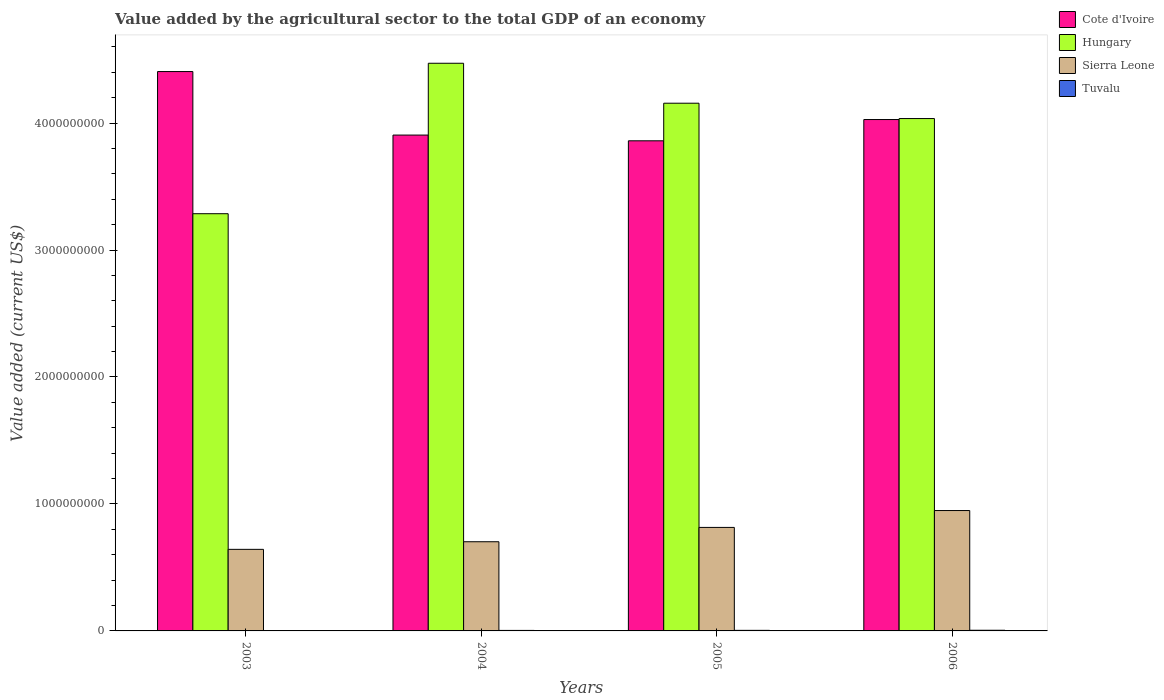How many groups of bars are there?
Offer a very short reply. 4. Are the number of bars on each tick of the X-axis equal?
Give a very brief answer. Yes. How many bars are there on the 1st tick from the left?
Ensure brevity in your answer.  4. How many bars are there on the 1st tick from the right?
Your answer should be compact. 4. What is the value added by the agricultural sector to the total GDP in Sierra Leone in 2006?
Ensure brevity in your answer.  9.48e+08. Across all years, what is the maximum value added by the agricultural sector to the total GDP in Sierra Leone?
Your answer should be compact. 9.48e+08. Across all years, what is the minimum value added by the agricultural sector to the total GDP in Tuvalu?
Offer a very short reply. 3.17e+06. In which year was the value added by the agricultural sector to the total GDP in Cote d'Ivoire maximum?
Your response must be concise. 2003. What is the total value added by the agricultural sector to the total GDP in Hungary in the graph?
Your answer should be very brief. 1.59e+1. What is the difference between the value added by the agricultural sector to the total GDP in Sierra Leone in 2004 and that in 2006?
Ensure brevity in your answer.  -2.46e+08. What is the difference between the value added by the agricultural sector to the total GDP in Tuvalu in 2003 and the value added by the agricultural sector to the total GDP in Sierra Leone in 2005?
Ensure brevity in your answer.  -8.12e+08. What is the average value added by the agricultural sector to the total GDP in Cote d'Ivoire per year?
Provide a short and direct response. 4.05e+09. In the year 2005, what is the difference between the value added by the agricultural sector to the total GDP in Hungary and value added by the agricultural sector to the total GDP in Tuvalu?
Offer a very short reply. 4.15e+09. What is the ratio of the value added by the agricultural sector to the total GDP in Hungary in 2003 to that in 2006?
Your response must be concise. 0.81. Is the difference between the value added by the agricultural sector to the total GDP in Hungary in 2003 and 2004 greater than the difference between the value added by the agricultural sector to the total GDP in Tuvalu in 2003 and 2004?
Give a very brief answer. No. What is the difference between the highest and the second highest value added by the agricultural sector to the total GDP in Cote d'Ivoire?
Provide a succinct answer. 3.78e+08. What is the difference between the highest and the lowest value added by the agricultural sector to the total GDP in Hungary?
Your answer should be very brief. 1.18e+09. In how many years, is the value added by the agricultural sector to the total GDP in Cote d'Ivoire greater than the average value added by the agricultural sector to the total GDP in Cote d'Ivoire taken over all years?
Your answer should be very brief. 1. Is the sum of the value added by the agricultural sector to the total GDP in Cote d'Ivoire in 2004 and 2005 greater than the maximum value added by the agricultural sector to the total GDP in Tuvalu across all years?
Your answer should be compact. Yes. Is it the case that in every year, the sum of the value added by the agricultural sector to the total GDP in Sierra Leone and value added by the agricultural sector to the total GDP in Cote d'Ivoire is greater than the sum of value added by the agricultural sector to the total GDP in Hungary and value added by the agricultural sector to the total GDP in Tuvalu?
Keep it short and to the point. Yes. What does the 1st bar from the left in 2005 represents?
Offer a very short reply. Cote d'Ivoire. What does the 4th bar from the right in 2006 represents?
Keep it short and to the point. Cote d'Ivoire. Are all the bars in the graph horizontal?
Keep it short and to the point. No. What is the difference between two consecutive major ticks on the Y-axis?
Your response must be concise. 1.00e+09. Does the graph contain any zero values?
Provide a succinct answer. No. How many legend labels are there?
Your response must be concise. 4. How are the legend labels stacked?
Keep it short and to the point. Vertical. What is the title of the graph?
Give a very brief answer. Value added by the agricultural sector to the total GDP of an economy. What is the label or title of the X-axis?
Provide a succinct answer. Years. What is the label or title of the Y-axis?
Offer a terse response. Value added (current US$). What is the Value added (current US$) in Cote d'Ivoire in 2003?
Provide a short and direct response. 4.41e+09. What is the Value added (current US$) in Hungary in 2003?
Keep it short and to the point. 3.29e+09. What is the Value added (current US$) in Sierra Leone in 2003?
Keep it short and to the point. 6.42e+08. What is the Value added (current US$) in Tuvalu in 2003?
Provide a short and direct response. 3.17e+06. What is the Value added (current US$) of Cote d'Ivoire in 2004?
Ensure brevity in your answer.  3.91e+09. What is the Value added (current US$) in Hungary in 2004?
Give a very brief answer. 4.47e+09. What is the Value added (current US$) of Sierra Leone in 2004?
Give a very brief answer. 7.02e+08. What is the Value added (current US$) of Tuvalu in 2004?
Offer a terse response. 4.02e+06. What is the Value added (current US$) in Cote d'Ivoire in 2005?
Ensure brevity in your answer.  3.86e+09. What is the Value added (current US$) of Hungary in 2005?
Your answer should be compact. 4.16e+09. What is the Value added (current US$) of Sierra Leone in 2005?
Keep it short and to the point. 8.15e+08. What is the Value added (current US$) of Tuvalu in 2005?
Offer a terse response. 4.45e+06. What is the Value added (current US$) in Cote d'Ivoire in 2006?
Your answer should be compact. 4.03e+09. What is the Value added (current US$) of Hungary in 2006?
Offer a terse response. 4.04e+09. What is the Value added (current US$) of Sierra Leone in 2006?
Give a very brief answer. 9.48e+08. What is the Value added (current US$) in Tuvalu in 2006?
Your answer should be very brief. 5.22e+06. Across all years, what is the maximum Value added (current US$) in Cote d'Ivoire?
Offer a terse response. 4.41e+09. Across all years, what is the maximum Value added (current US$) in Hungary?
Your answer should be very brief. 4.47e+09. Across all years, what is the maximum Value added (current US$) of Sierra Leone?
Provide a succinct answer. 9.48e+08. Across all years, what is the maximum Value added (current US$) of Tuvalu?
Give a very brief answer. 5.22e+06. Across all years, what is the minimum Value added (current US$) of Cote d'Ivoire?
Provide a short and direct response. 3.86e+09. Across all years, what is the minimum Value added (current US$) of Hungary?
Provide a succinct answer. 3.29e+09. Across all years, what is the minimum Value added (current US$) in Sierra Leone?
Provide a succinct answer. 6.42e+08. Across all years, what is the minimum Value added (current US$) of Tuvalu?
Make the answer very short. 3.17e+06. What is the total Value added (current US$) in Cote d'Ivoire in the graph?
Make the answer very short. 1.62e+1. What is the total Value added (current US$) of Hungary in the graph?
Give a very brief answer. 1.59e+1. What is the total Value added (current US$) of Sierra Leone in the graph?
Make the answer very short. 3.11e+09. What is the total Value added (current US$) in Tuvalu in the graph?
Give a very brief answer. 1.69e+07. What is the difference between the Value added (current US$) of Cote d'Ivoire in 2003 and that in 2004?
Give a very brief answer. 5.00e+08. What is the difference between the Value added (current US$) in Hungary in 2003 and that in 2004?
Your response must be concise. -1.18e+09. What is the difference between the Value added (current US$) of Sierra Leone in 2003 and that in 2004?
Make the answer very short. -5.99e+07. What is the difference between the Value added (current US$) of Tuvalu in 2003 and that in 2004?
Ensure brevity in your answer.  -8.54e+05. What is the difference between the Value added (current US$) of Cote d'Ivoire in 2003 and that in 2005?
Offer a terse response. 5.45e+08. What is the difference between the Value added (current US$) of Hungary in 2003 and that in 2005?
Your answer should be very brief. -8.70e+08. What is the difference between the Value added (current US$) in Sierra Leone in 2003 and that in 2005?
Your answer should be compact. -1.73e+08. What is the difference between the Value added (current US$) in Tuvalu in 2003 and that in 2005?
Provide a succinct answer. -1.28e+06. What is the difference between the Value added (current US$) of Cote d'Ivoire in 2003 and that in 2006?
Offer a very short reply. 3.78e+08. What is the difference between the Value added (current US$) in Hungary in 2003 and that in 2006?
Keep it short and to the point. -7.49e+08. What is the difference between the Value added (current US$) in Sierra Leone in 2003 and that in 2006?
Your answer should be compact. -3.06e+08. What is the difference between the Value added (current US$) of Tuvalu in 2003 and that in 2006?
Make the answer very short. -2.05e+06. What is the difference between the Value added (current US$) of Cote d'Ivoire in 2004 and that in 2005?
Your response must be concise. 4.51e+07. What is the difference between the Value added (current US$) in Hungary in 2004 and that in 2005?
Give a very brief answer. 3.15e+08. What is the difference between the Value added (current US$) in Sierra Leone in 2004 and that in 2005?
Your answer should be very brief. -1.13e+08. What is the difference between the Value added (current US$) in Tuvalu in 2004 and that in 2005?
Ensure brevity in your answer.  -4.29e+05. What is the difference between the Value added (current US$) of Cote d'Ivoire in 2004 and that in 2006?
Your answer should be very brief. -1.22e+08. What is the difference between the Value added (current US$) of Hungary in 2004 and that in 2006?
Offer a terse response. 4.35e+08. What is the difference between the Value added (current US$) in Sierra Leone in 2004 and that in 2006?
Provide a short and direct response. -2.46e+08. What is the difference between the Value added (current US$) of Tuvalu in 2004 and that in 2006?
Keep it short and to the point. -1.20e+06. What is the difference between the Value added (current US$) of Cote d'Ivoire in 2005 and that in 2006?
Your response must be concise. -1.67e+08. What is the difference between the Value added (current US$) in Hungary in 2005 and that in 2006?
Your response must be concise. 1.21e+08. What is the difference between the Value added (current US$) of Sierra Leone in 2005 and that in 2006?
Your answer should be compact. -1.33e+08. What is the difference between the Value added (current US$) in Tuvalu in 2005 and that in 2006?
Offer a very short reply. -7.67e+05. What is the difference between the Value added (current US$) of Cote d'Ivoire in 2003 and the Value added (current US$) of Hungary in 2004?
Provide a succinct answer. -6.54e+07. What is the difference between the Value added (current US$) of Cote d'Ivoire in 2003 and the Value added (current US$) of Sierra Leone in 2004?
Offer a terse response. 3.70e+09. What is the difference between the Value added (current US$) in Cote d'Ivoire in 2003 and the Value added (current US$) in Tuvalu in 2004?
Provide a succinct answer. 4.40e+09. What is the difference between the Value added (current US$) of Hungary in 2003 and the Value added (current US$) of Sierra Leone in 2004?
Your answer should be very brief. 2.58e+09. What is the difference between the Value added (current US$) of Hungary in 2003 and the Value added (current US$) of Tuvalu in 2004?
Give a very brief answer. 3.28e+09. What is the difference between the Value added (current US$) of Sierra Leone in 2003 and the Value added (current US$) of Tuvalu in 2004?
Ensure brevity in your answer.  6.38e+08. What is the difference between the Value added (current US$) of Cote d'Ivoire in 2003 and the Value added (current US$) of Hungary in 2005?
Make the answer very short. 2.49e+08. What is the difference between the Value added (current US$) of Cote d'Ivoire in 2003 and the Value added (current US$) of Sierra Leone in 2005?
Make the answer very short. 3.59e+09. What is the difference between the Value added (current US$) of Cote d'Ivoire in 2003 and the Value added (current US$) of Tuvalu in 2005?
Ensure brevity in your answer.  4.40e+09. What is the difference between the Value added (current US$) in Hungary in 2003 and the Value added (current US$) in Sierra Leone in 2005?
Offer a very short reply. 2.47e+09. What is the difference between the Value added (current US$) in Hungary in 2003 and the Value added (current US$) in Tuvalu in 2005?
Provide a short and direct response. 3.28e+09. What is the difference between the Value added (current US$) in Sierra Leone in 2003 and the Value added (current US$) in Tuvalu in 2005?
Provide a succinct answer. 6.38e+08. What is the difference between the Value added (current US$) of Cote d'Ivoire in 2003 and the Value added (current US$) of Hungary in 2006?
Make the answer very short. 3.70e+08. What is the difference between the Value added (current US$) of Cote d'Ivoire in 2003 and the Value added (current US$) of Sierra Leone in 2006?
Offer a very short reply. 3.46e+09. What is the difference between the Value added (current US$) in Cote d'Ivoire in 2003 and the Value added (current US$) in Tuvalu in 2006?
Your answer should be compact. 4.40e+09. What is the difference between the Value added (current US$) of Hungary in 2003 and the Value added (current US$) of Sierra Leone in 2006?
Your answer should be compact. 2.34e+09. What is the difference between the Value added (current US$) in Hungary in 2003 and the Value added (current US$) in Tuvalu in 2006?
Give a very brief answer. 3.28e+09. What is the difference between the Value added (current US$) in Sierra Leone in 2003 and the Value added (current US$) in Tuvalu in 2006?
Your answer should be very brief. 6.37e+08. What is the difference between the Value added (current US$) in Cote d'Ivoire in 2004 and the Value added (current US$) in Hungary in 2005?
Ensure brevity in your answer.  -2.51e+08. What is the difference between the Value added (current US$) of Cote d'Ivoire in 2004 and the Value added (current US$) of Sierra Leone in 2005?
Offer a very short reply. 3.09e+09. What is the difference between the Value added (current US$) in Cote d'Ivoire in 2004 and the Value added (current US$) in Tuvalu in 2005?
Offer a very short reply. 3.90e+09. What is the difference between the Value added (current US$) of Hungary in 2004 and the Value added (current US$) of Sierra Leone in 2005?
Offer a terse response. 3.66e+09. What is the difference between the Value added (current US$) in Hungary in 2004 and the Value added (current US$) in Tuvalu in 2005?
Offer a terse response. 4.47e+09. What is the difference between the Value added (current US$) of Sierra Leone in 2004 and the Value added (current US$) of Tuvalu in 2005?
Provide a short and direct response. 6.98e+08. What is the difference between the Value added (current US$) of Cote d'Ivoire in 2004 and the Value added (current US$) of Hungary in 2006?
Keep it short and to the point. -1.30e+08. What is the difference between the Value added (current US$) of Cote d'Ivoire in 2004 and the Value added (current US$) of Sierra Leone in 2006?
Keep it short and to the point. 2.96e+09. What is the difference between the Value added (current US$) in Cote d'Ivoire in 2004 and the Value added (current US$) in Tuvalu in 2006?
Your response must be concise. 3.90e+09. What is the difference between the Value added (current US$) of Hungary in 2004 and the Value added (current US$) of Sierra Leone in 2006?
Ensure brevity in your answer.  3.52e+09. What is the difference between the Value added (current US$) of Hungary in 2004 and the Value added (current US$) of Tuvalu in 2006?
Your response must be concise. 4.47e+09. What is the difference between the Value added (current US$) of Sierra Leone in 2004 and the Value added (current US$) of Tuvalu in 2006?
Provide a succinct answer. 6.97e+08. What is the difference between the Value added (current US$) in Cote d'Ivoire in 2005 and the Value added (current US$) in Hungary in 2006?
Your answer should be very brief. -1.75e+08. What is the difference between the Value added (current US$) of Cote d'Ivoire in 2005 and the Value added (current US$) of Sierra Leone in 2006?
Your answer should be very brief. 2.91e+09. What is the difference between the Value added (current US$) in Cote d'Ivoire in 2005 and the Value added (current US$) in Tuvalu in 2006?
Your answer should be very brief. 3.85e+09. What is the difference between the Value added (current US$) in Hungary in 2005 and the Value added (current US$) in Sierra Leone in 2006?
Provide a short and direct response. 3.21e+09. What is the difference between the Value added (current US$) in Hungary in 2005 and the Value added (current US$) in Tuvalu in 2006?
Give a very brief answer. 4.15e+09. What is the difference between the Value added (current US$) in Sierra Leone in 2005 and the Value added (current US$) in Tuvalu in 2006?
Your response must be concise. 8.10e+08. What is the average Value added (current US$) in Cote d'Ivoire per year?
Provide a short and direct response. 4.05e+09. What is the average Value added (current US$) in Hungary per year?
Provide a short and direct response. 3.99e+09. What is the average Value added (current US$) of Sierra Leone per year?
Your answer should be compact. 7.77e+08. What is the average Value added (current US$) in Tuvalu per year?
Keep it short and to the point. 4.22e+06. In the year 2003, what is the difference between the Value added (current US$) of Cote d'Ivoire and Value added (current US$) of Hungary?
Your response must be concise. 1.12e+09. In the year 2003, what is the difference between the Value added (current US$) of Cote d'Ivoire and Value added (current US$) of Sierra Leone?
Your answer should be very brief. 3.76e+09. In the year 2003, what is the difference between the Value added (current US$) in Cote d'Ivoire and Value added (current US$) in Tuvalu?
Ensure brevity in your answer.  4.40e+09. In the year 2003, what is the difference between the Value added (current US$) in Hungary and Value added (current US$) in Sierra Leone?
Provide a short and direct response. 2.64e+09. In the year 2003, what is the difference between the Value added (current US$) of Hungary and Value added (current US$) of Tuvalu?
Ensure brevity in your answer.  3.28e+09. In the year 2003, what is the difference between the Value added (current US$) of Sierra Leone and Value added (current US$) of Tuvalu?
Your answer should be compact. 6.39e+08. In the year 2004, what is the difference between the Value added (current US$) in Cote d'Ivoire and Value added (current US$) in Hungary?
Give a very brief answer. -5.66e+08. In the year 2004, what is the difference between the Value added (current US$) in Cote d'Ivoire and Value added (current US$) in Sierra Leone?
Ensure brevity in your answer.  3.20e+09. In the year 2004, what is the difference between the Value added (current US$) in Cote d'Ivoire and Value added (current US$) in Tuvalu?
Provide a succinct answer. 3.90e+09. In the year 2004, what is the difference between the Value added (current US$) of Hungary and Value added (current US$) of Sierra Leone?
Ensure brevity in your answer.  3.77e+09. In the year 2004, what is the difference between the Value added (current US$) in Hungary and Value added (current US$) in Tuvalu?
Your answer should be very brief. 4.47e+09. In the year 2004, what is the difference between the Value added (current US$) in Sierra Leone and Value added (current US$) in Tuvalu?
Your answer should be very brief. 6.98e+08. In the year 2005, what is the difference between the Value added (current US$) in Cote d'Ivoire and Value added (current US$) in Hungary?
Provide a succinct answer. -2.96e+08. In the year 2005, what is the difference between the Value added (current US$) in Cote d'Ivoire and Value added (current US$) in Sierra Leone?
Give a very brief answer. 3.04e+09. In the year 2005, what is the difference between the Value added (current US$) of Cote d'Ivoire and Value added (current US$) of Tuvalu?
Provide a succinct answer. 3.86e+09. In the year 2005, what is the difference between the Value added (current US$) in Hungary and Value added (current US$) in Sierra Leone?
Your answer should be compact. 3.34e+09. In the year 2005, what is the difference between the Value added (current US$) of Hungary and Value added (current US$) of Tuvalu?
Keep it short and to the point. 4.15e+09. In the year 2005, what is the difference between the Value added (current US$) of Sierra Leone and Value added (current US$) of Tuvalu?
Make the answer very short. 8.11e+08. In the year 2006, what is the difference between the Value added (current US$) of Cote d'Ivoire and Value added (current US$) of Hungary?
Offer a terse response. -7.77e+06. In the year 2006, what is the difference between the Value added (current US$) in Cote d'Ivoire and Value added (current US$) in Sierra Leone?
Provide a short and direct response. 3.08e+09. In the year 2006, what is the difference between the Value added (current US$) of Cote d'Ivoire and Value added (current US$) of Tuvalu?
Ensure brevity in your answer.  4.02e+09. In the year 2006, what is the difference between the Value added (current US$) of Hungary and Value added (current US$) of Sierra Leone?
Keep it short and to the point. 3.09e+09. In the year 2006, what is the difference between the Value added (current US$) of Hungary and Value added (current US$) of Tuvalu?
Provide a succinct answer. 4.03e+09. In the year 2006, what is the difference between the Value added (current US$) of Sierra Leone and Value added (current US$) of Tuvalu?
Ensure brevity in your answer.  9.43e+08. What is the ratio of the Value added (current US$) in Cote d'Ivoire in 2003 to that in 2004?
Provide a succinct answer. 1.13. What is the ratio of the Value added (current US$) in Hungary in 2003 to that in 2004?
Provide a short and direct response. 0.73. What is the ratio of the Value added (current US$) in Sierra Leone in 2003 to that in 2004?
Give a very brief answer. 0.91. What is the ratio of the Value added (current US$) of Tuvalu in 2003 to that in 2004?
Your answer should be very brief. 0.79. What is the ratio of the Value added (current US$) of Cote d'Ivoire in 2003 to that in 2005?
Give a very brief answer. 1.14. What is the ratio of the Value added (current US$) in Hungary in 2003 to that in 2005?
Your answer should be compact. 0.79. What is the ratio of the Value added (current US$) in Sierra Leone in 2003 to that in 2005?
Ensure brevity in your answer.  0.79. What is the ratio of the Value added (current US$) of Tuvalu in 2003 to that in 2005?
Give a very brief answer. 0.71. What is the ratio of the Value added (current US$) in Cote d'Ivoire in 2003 to that in 2006?
Keep it short and to the point. 1.09. What is the ratio of the Value added (current US$) of Hungary in 2003 to that in 2006?
Your answer should be compact. 0.81. What is the ratio of the Value added (current US$) in Sierra Leone in 2003 to that in 2006?
Offer a very short reply. 0.68. What is the ratio of the Value added (current US$) of Tuvalu in 2003 to that in 2006?
Your response must be concise. 0.61. What is the ratio of the Value added (current US$) of Cote d'Ivoire in 2004 to that in 2005?
Your answer should be compact. 1.01. What is the ratio of the Value added (current US$) in Hungary in 2004 to that in 2005?
Your answer should be very brief. 1.08. What is the ratio of the Value added (current US$) of Sierra Leone in 2004 to that in 2005?
Your answer should be very brief. 0.86. What is the ratio of the Value added (current US$) of Tuvalu in 2004 to that in 2005?
Ensure brevity in your answer.  0.9. What is the ratio of the Value added (current US$) in Cote d'Ivoire in 2004 to that in 2006?
Give a very brief answer. 0.97. What is the ratio of the Value added (current US$) in Hungary in 2004 to that in 2006?
Make the answer very short. 1.11. What is the ratio of the Value added (current US$) in Sierra Leone in 2004 to that in 2006?
Offer a terse response. 0.74. What is the ratio of the Value added (current US$) of Tuvalu in 2004 to that in 2006?
Your answer should be compact. 0.77. What is the ratio of the Value added (current US$) in Cote d'Ivoire in 2005 to that in 2006?
Offer a very short reply. 0.96. What is the ratio of the Value added (current US$) of Hungary in 2005 to that in 2006?
Provide a short and direct response. 1.03. What is the ratio of the Value added (current US$) in Sierra Leone in 2005 to that in 2006?
Make the answer very short. 0.86. What is the ratio of the Value added (current US$) in Tuvalu in 2005 to that in 2006?
Your answer should be very brief. 0.85. What is the difference between the highest and the second highest Value added (current US$) in Cote d'Ivoire?
Your response must be concise. 3.78e+08. What is the difference between the highest and the second highest Value added (current US$) in Hungary?
Keep it short and to the point. 3.15e+08. What is the difference between the highest and the second highest Value added (current US$) of Sierra Leone?
Provide a succinct answer. 1.33e+08. What is the difference between the highest and the second highest Value added (current US$) in Tuvalu?
Provide a short and direct response. 7.67e+05. What is the difference between the highest and the lowest Value added (current US$) in Cote d'Ivoire?
Offer a terse response. 5.45e+08. What is the difference between the highest and the lowest Value added (current US$) of Hungary?
Provide a succinct answer. 1.18e+09. What is the difference between the highest and the lowest Value added (current US$) in Sierra Leone?
Give a very brief answer. 3.06e+08. What is the difference between the highest and the lowest Value added (current US$) in Tuvalu?
Offer a terse response. 2.05e+06. 